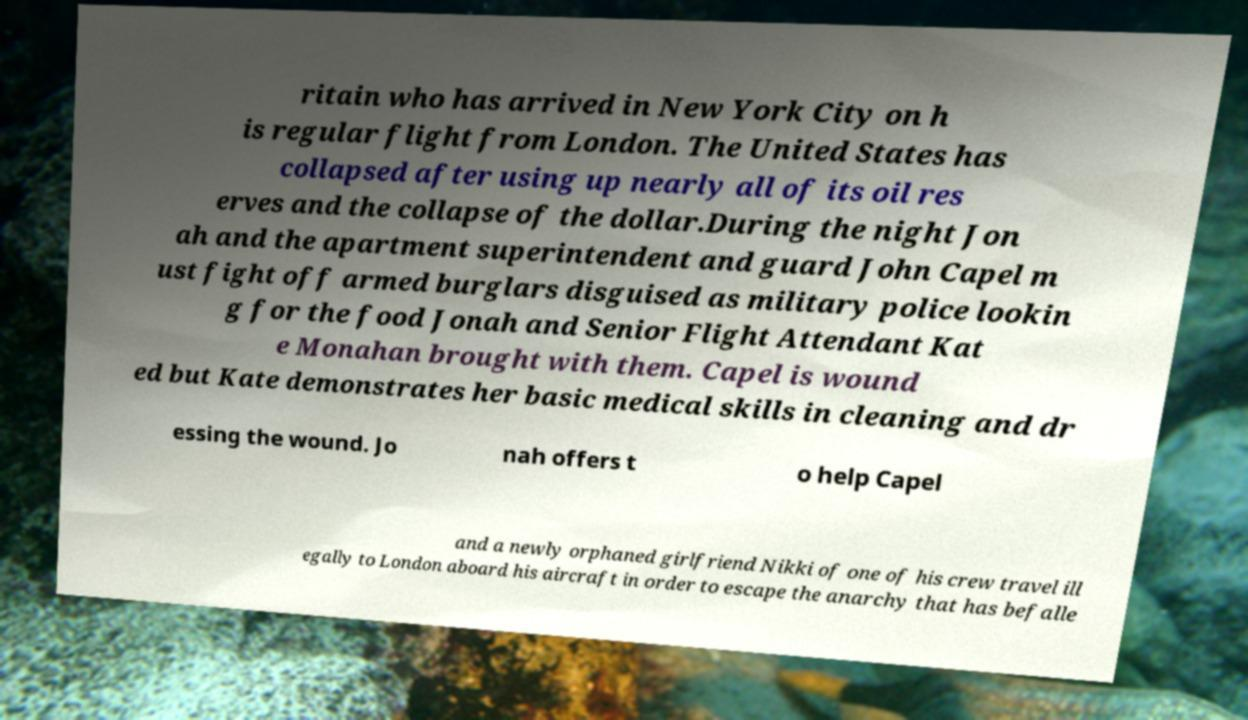There's text embedded in this image that I need extracted. Can you transcribe it verbatim? ritain who has arrived in New York City on h is regular flight from London. The United States has collapsed after using up nearly all of its oil res erves and the collapse of the dollar.During the night Jon ah and the apartment superintendent and guard John Capel m ust fight off armed burglars disguised as military police lookin g for the food Jonah and Senior Flight Attendant Kat e Monahan brought with them. Capel is wound ed but Kate demonstrates her basic medical skills in cleaning and dr essing the wound. Jo nah offers t o help Capel and a newly orphaned girlfriend Nikki of one of his crew travel ill egally to London aboard his aircraft in order to escape the anarchy that has befalle 